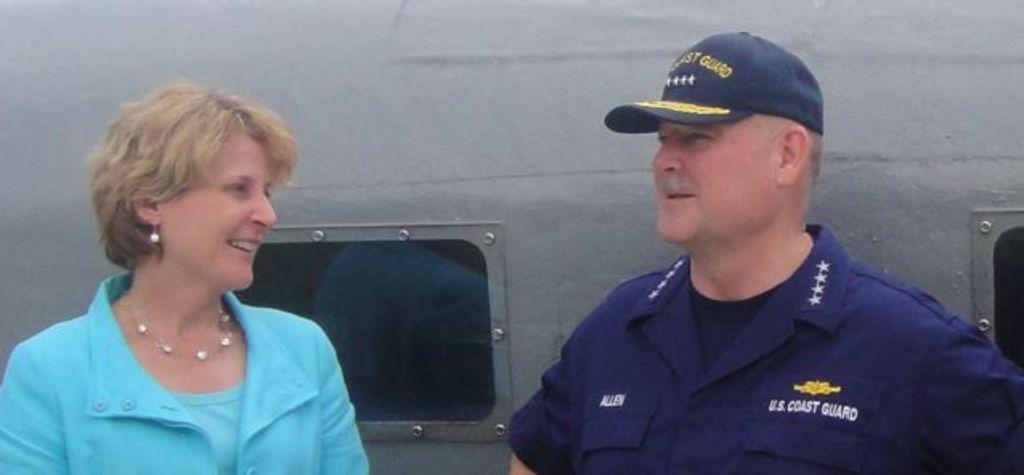Provide a one-sentence caption for the provided image. A woman is speaking to a man from the U.S. Coast Guard. 